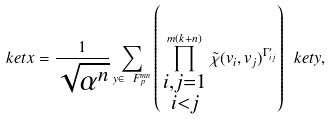Convert formula to latex. <formula><loc_0><loc_0><loc_500><loc_500>\ k e t { x } = \frac { 1 } { \sqrt { \alpha ^ { n } } } \sum _ { y \in \ F _ { p } ^ { m n } } \left ( \prod _ { \begin{smallmatrix} i , j = 1 \\ i < j \end{smallmatrix} } ^ { m ( k + n ) } \tilde { \chi } ( v _ { i } , v _ { j } ) ^ { \Gamma ^ { \prime } _ { i j } } \right ) \ k e t { y } ,</formula> 